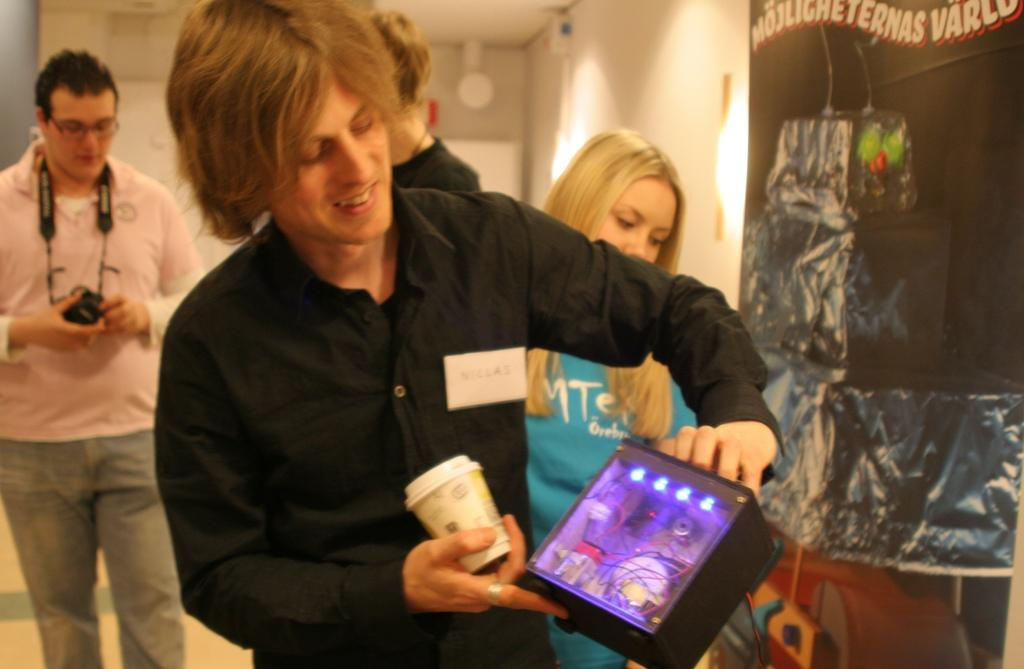What is the main subject of the image? There is a person standing in the center of the image. What is the person in the center holding? The person is holding a cup. Can you describe the background of the image? There is a person with a camera, a woman, lights, and a wall visible in the background. What type of crate is being used to store the fire in the image? There is no fire or crate present in the image. 